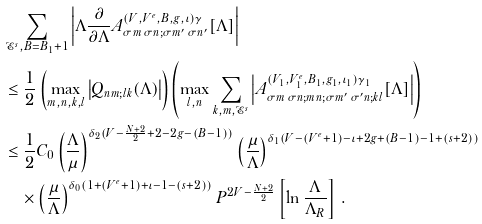<formula> <loc_0><loc_0><loc_500><loc_500>& \sum _ { \mathcal { E } ^ { s } , B = B _ { 1 } + 1 } \left | \Lambda \frac { \partial } { \partial \Lambda } A ^ { ( V , V ^ { e } , B , g , \iota ) \gamma } _ { \sigma m \, \sigma n ; \sigma m ^ { \prime } \, \sigma n ^ { \prime } } [ \Lambda ] \right | \\ & \leq \frac { 1 } { 2 } \left ( \max _ { m , n , k , l } \left | Q _ { n m ; l k } ( \Lambda ) \right | \right ) \left ( \max _ { l , n } \sum _ { k , m , \mathcal { E } ^ { s } } \left | A ^ { ( V _ { 1 } , V ^ { e } _ { 1 } , B _ { 1 } , g _ { 1 } , \iota _ { 1 } ) \gamma _ { 1 } } _ { \sigma m \, \sigma n ; m n ; \sigma m ^ { \prime } \, \sigma ^ { \prime } n ; k l } [ \Lambda ] \right | \right ) \\ & \leq \frac { 1 } { 2 } C _ { 0 } \left ( \frac { \Lambda } { \mu } \right ) ^ { \delta _ { 2 } ( V - \frac { N + 2 } { 2 } + 2 - 2 g - ( B - 1 ) ) } \left ( \frac { \mu } { \Lambda } \right ) ^ { \delta _ { 1 } ( V - ( V ^ { e } + 1 ) - \iota + 2 g + ( B - 1 ) - 1 + ( s + 2 ) ) } \\ & \quad \times \left ( \frac { \mu } { \Lambda } \right ) ^ { \delta _ { 0 } ( 1 + ( V ^ { e } + 1 ) + \iota - 1 - ( s + 2 ) ) } P ^ { 2 V - \frac { N + 2 } { 2 } } \left [ \ln \frac { \Lambda } { \Lambda _ { R } } \right ] \, .</formula> 